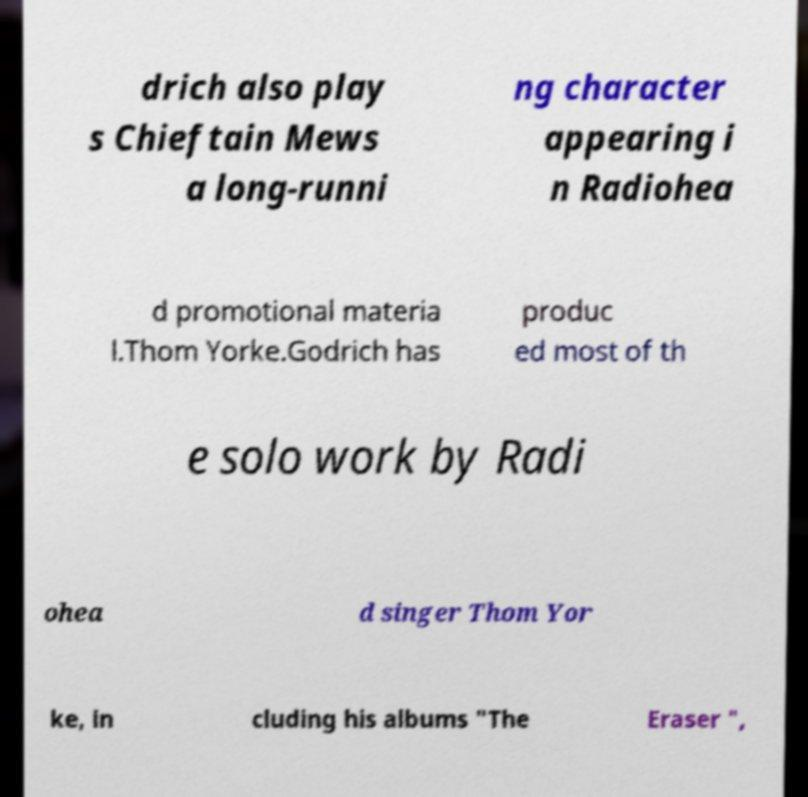Can you accurately transcribe the text from the provided image for me? drich also play s Chieftain Mews a long-runni ng character appearing i n Radiohea d promotional materia l.Thom Yorke.Godrich has produc ed most of th e solo work by Radi ohea d singer Thom Yor ke, in cluding his albums "The Eraser ", 